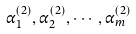<formula> <loc_0><loc_0><loc_500><loc_500>\alpha ^ { ( 2 ) } _ { 1 } , \alpha ^ { ( 2 ) } _ { 2 } , \cdots , \alpha ^ { ( 2 ) } _ { m }</formula> 